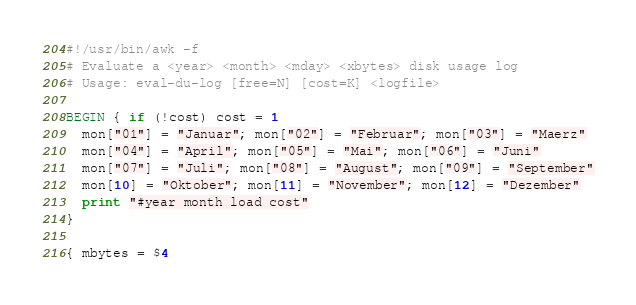<code> <loc_0><loc_0><loc_500><loc_500><_Awk_>#!/usr/bin/awk -f
# Evaluate a <year> <month> <mday> <xbytes> disk usage log
# Usage: eval-du-log [free=N] [cost=K] <logfile>

BEGIN { if (!cost) cost = 1
  mon["01"] = "Januar"; mon["02"] = "Februar"; mon["03"] = "Maerz"
  mon["04"] = "April"; mon["05"] = "Mai"; mon["06"] = "Juni"
  mon["07"] = "Juli"; mon["08"] = "August"; mon["09"] = "September"
  mon[10] = "Oktober"; mon[11] = "November"; mon[12] = "Dezember"
  print "#year month load cost"
}

{ mbytes = $4</code> 